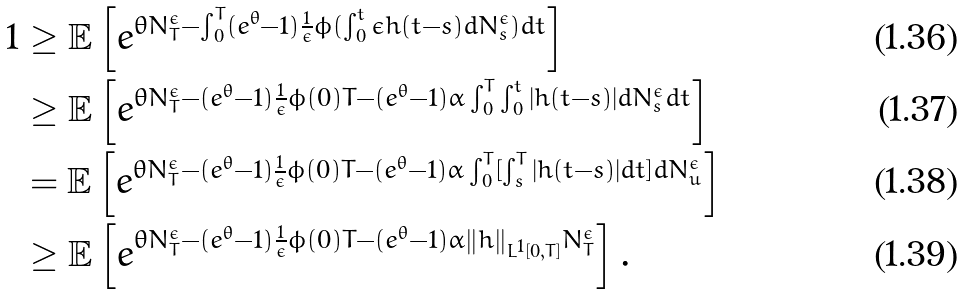<formula> <loc_0><loc_0><loc_500><loc_500>1 & \geq \mathbb { E } \left [ e ^ { \theta N _ { T } ^ { \epsilon } - \int _ { 0 } ^ { T } ( e ^ { \theta } - 1 ) \frac { 1 } { \epsilon } \phi ( \int _ { 0 } ^ { t } \epsilon h ( t - s ) d N _ { s } ^ { \epsilon } ) d t } \right ] \\ & \geq \mathbb { E } \left [ e ^ { \theta N _ { T } ^ { \epsilon } - ( e ^ { \theta } - 1 ) \frac { 1 } { \epsilon } \phi ( 0 ) T - ( e ^ { \theta } - 1 ) \alpha \int _ { 0 } ^ { T } \int _ { 0 } ^ { t } | h ( t - s ) | d N _ { s } ^ { \epsilon } d t } \right ] \\ & = \mathbb { E } \left [ e ^ { \theta N _ { T } ^ { \epsilon } - ( e ^ { \theta } - 1 ) \frac { 1 } { \epsilon } \phi ( 0 ) T - ( e ^ { \theta } - 1 ) \alpha \int _ { 0 } ^ { T } [ \int _ { s } ^ { T } | h ( t - s ) | d t ] d N _ { u } ^ { \epsilon } } \right ] \\ & \geq \mathbb { E } \left [ e ^ { \theta N _ { T } ^ { \epsilon } - ( e ^ { \theta } - 1 ) \frac { 1 } { \epsilon } \phi ( 0 ) T - ( e ^ { \theta } - 1 ) \alpha \| h \| _ { L ^ { 1 } [ 0 , T ] } N _ { T } ^ { \epsilon } } \right ] .</formula> 